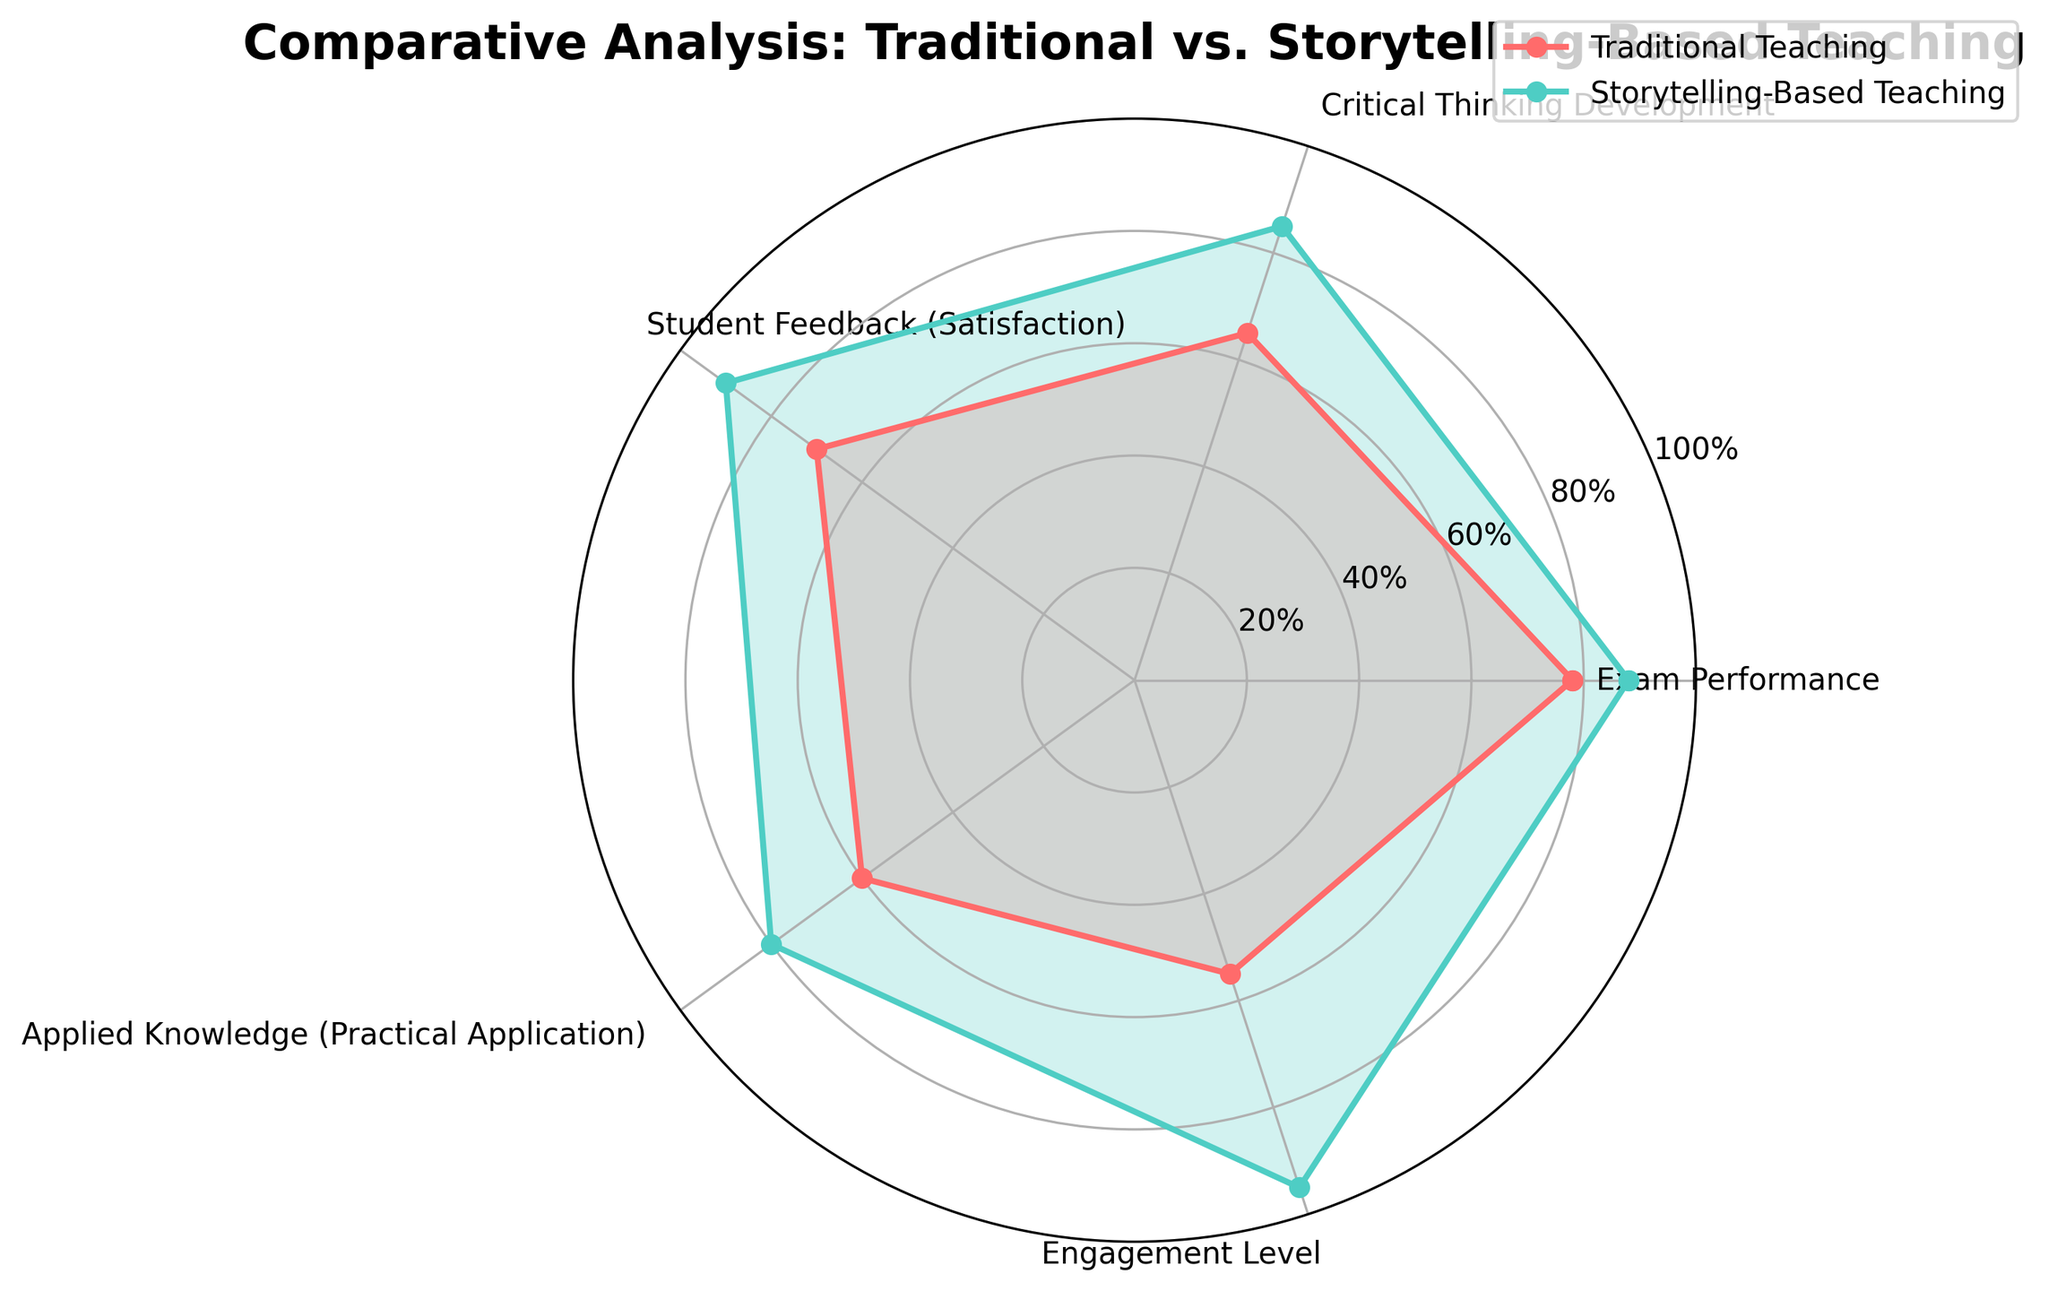What's the title of the radar chart? The radar chart's title is clearly located at the top center, reading "Comparative Analysis: Traditional vs. Storytelling-Based Teaching".
Answer: Comparative Analysis: Traditional vs. Storytelling-Based Teaching Which teaching method has higher exam performance? By comparing the values for exam performance on the radar chart, we see that storytelling-based teaching scores 88, while traditional teaching scores 78.
Answer: Storytelling-Based Teaching Which category shows the greatest difference in performance between the two teaching methods? Look at all the categories and calculate the differences: Exam Performance (88-78 = 10), Critical Thinking Development (85-65 = 20), Student Feedback (90-70 = 20), Applied Knowledge (80-60 = 20), and Engagement Level (95-55 = 40). The greatest difference is in Engagement Level (95-55).
Answer: Engagement Level How many metrics show storytelling-based teaching outperforming traditional teaching? In each category on the radar chart, compare the values for both teaching methods: Exam Performance (88 > 78), Critical Thinking Development (85 > 65), Student Feedback (90 > 70), Applied Knowledge (80 > 60), Engagement Level (95 > 55). All five metrics show storytelling-based teaching outperforming traditional.
Answer: 5 What is the average value of student feedback and engagement levels for traditional teaching? Sum the values for student feedback and engagement levels: 70 (Student Feedback) + 55 (Engagement Level) = 125. Divide by 2: 125 / 2 = 62.5.
Answer: 62.5 What is the difference between storytelling-based and traditional teaching in applied knowledge? The radar chart shows applied knowledge scores of 80 for storytelling-based teaching and 60 for traditional teaching. The difference is 80 - 60.
Answer: 20 Which metric does traditional teaching have the lowest value? Among the values for traditional teaching, the lowest one is in Engagement Level, which is 55.
Answer: Engagement Level By how much does storytelling-based teaching improve critical thinking development compared to traditional teaching? The radar chart shows critical thinking development scores of 85 for storytelling-based teaching and 65 for traditional teaching. The difference is 85 - 65.
Answer: 20 What are the maximum values for the radar chart's y-axis? The y-axis on the radar chart measures performance from 0% to 100%, with tick marks at intervals of 20%.
Answer: 100% 